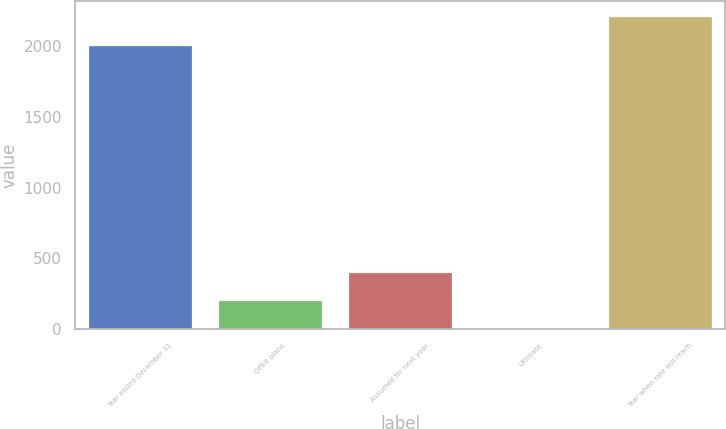Convert chart to OTSL. <chart><loc_0><loc_0><loc_500><loc_500><bar_chart><fcel>Year ended December 31<fcel>OPEB plans<fcel>Assumed for next year<fcel>Ultimate<fcel>Year when rate will reach<nl><fcel>2007<fcel>205.9<fcel>406.8<fcel>5<fcel>2207.9<nl></chart> 